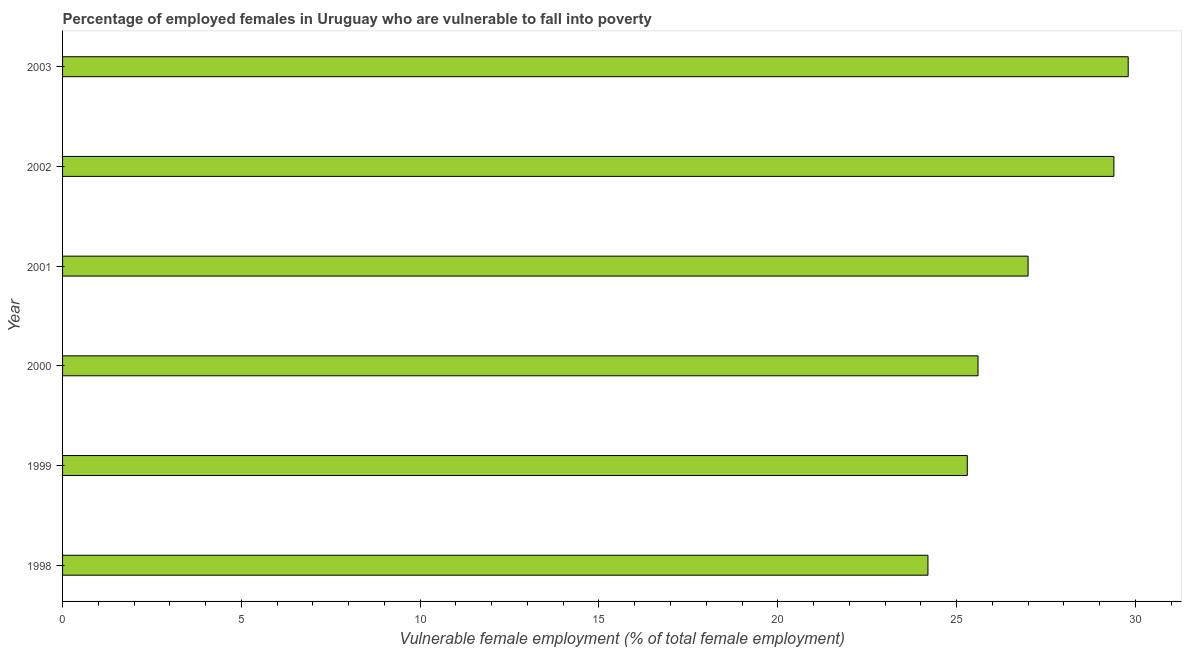Does the graph contain grids?
Your response must be concise. No. What is the title of the graph?
Provide a short and direct response. Percentage of employed females in Uruguay who are vulnerable to fall into poverty. What is the label or title of the X-axis?
Provide a succinct answer. Vulnerable female employment (% of total female employment). What is the percentage of employed females who are vulnerable to fall into poverty in 2000?
Your answer should be compact. 25.6. Across all years, what is the maximum percentage of employed females who are vulnerable to fall into poverty?
Provide a succinct answer. 29.8. Across all years, what is the minimum percentage of employed females who are vulnerable to fall into poverty?
Your answer should be compact. 24.2. What is the sum of the percentage of employed females who are vulnerable to fall into poverty?
Your answer should be very brief. 161.3. What is the average percentage of employed females who are vulnerable to fall into poverty per year?
Provide a short and direct response. 26.88. What is the median percentage of employed females who are vulnerable to fall into poverty?
Ensure brevity in your answer.  26.3. In how many years, is the percentage of employed females who are vulnerable to fall into poverty greater than 3 %?
Your response must be concise. 6. What is the ratio of the percentage of employed females who are vulnerable to fall into poverty in 2000 to that in 2001?
Offer a very short reply. 0.95. Is the difference between the percentage of employed females who are vulnerable to fall into poverty in 1998 and 2002 greater than the difference between any two years?
Give a very brief answer. No. What is the difference between the highest and the second highest percentage of employed females who are vulnerable to fall into poverty?
Offer a very short reply. 0.4. Is the sum of the percentage of employed females who are vulnerable to fall into poverty in 1998 and 2000 greater than the maximum percentage of employed females who are vulnerable to fall into poverty across all years?
Give a very brief answer. Yes. How many bars are there?
Give a very brief answer. 6. Are the values on the major ticks of X-axis written in scientific E-notation?
Make the answer very short. No. What is the Vulnerable female employment (% of total female employment) of 1998?
Your answer should be very brief. 24.2. What is the Vulnerable female employment (% of total female employment) in 1999?
Provide a short and direct response. 25.3. What is the Vulnerable female employment (% of total female employment) in 2000?
Your answer should be compact. 25.6. What is the Vulnerable female employment (% of total female employment) of 2001?
Give a very brief answer. 27. What is the Vulnerable female employment (% of total female employment) of 2002?
Your answer should be compact. 29.4. What is the Vulnerable female employment (% of total female employment) in 2003?
Provide a short and direct response. 29.8. What is the difference between the Vulnerable female employment (% of total female employment) in 1998 and 1999?
Your answer should be compact. -1.1. What is the difference between the Vulnerable female employment (% of total female employment) in 1998 and 2002?
Provide a succinct answer. -5.2. What is the difference between the Vulnerable female employment (% of total female employment) in 1998 and 2003?
Offer a very short reply. -5.6. What is the difference between the Vulnerable female employment (% of total female employment) in 1999 and 2001?
Your answer should be very brief. -1.7. What is the difference between the Vulnerable female employment (% of total female employment) in 2000 and 2001?
Provide a succinct answer. -1.4. What is the difference between the Vulnerable female employment (% of total female employment) in 2000 and 2002?
Offer a very short reply. -3.8. What is the difference between the Vulnerable female employment (% of total female employment) in 2000 and 2003?
Offer a terse response. -4.2. What is the difference between the Vulnerable female employment (% of total female employment) in 2001 and 2002?
Give a very brief answer. -2.4. What is the difference between the Vulnerable female employment (% of total female employment) in 2002 and 2003?
Your answer should be compact. -0.4. What is the ratio of the Vulnerable female employment (% of total female employment) in 1998 to that in 1999?
Your response must be concise. 0.96. What is the ratio of the Vulnerable female employment (% of total female employment) in 1998 to that in 2000?
Provide a succinct answer. 0.94. What is the ratio of the Vulnerable female employment (% of total female employment) in 1998 to that in 2001?
Keep it short and to the point. 0.9. What is the ratio of the Vulnerable female employment (% of total female employment) in 1998 to that in 2002?
Offer a very short reply. 0.82. What is the ratio of the Vulnerable female employment (% of total female employment) in 1998 to that in 2003?
Your answer should be compact. 0.81. What is the ratio of the Vulnerable female employment (% of total female employment) in 1999 to that in 2001?
Ensure brevity in your answer.  0.94. What is the ratio of the Vulnerable female employment (% of total female employment) in 1999 to that in 2002?
Offer a very short reply. 0.86. What is the ratio of the Vulnerable female employment (% of total female employment) in 1999 to that in 2003?
Make the answer very short. 0.85. What is the ratio of the Vulnerable female employment (% of total female employment) in 2000 to that in 2001?
Provide a short and direct response. 0.95. What is the ratio of the Vulnerable female employment (% of total female employment) in 2000 to that in 2002?
Offer a terse response. 0.87. What is the ratio of the Vulnerable female employment (% of total female employment) in 2000 to that in 2003?
Keep it short and to the point. 0.86. What is the ratio of the Vulnerable female employment (% of total female employment) in 2001 to that in 2002?
Ensure brevity in your answer.  0.92. What is the ratio of the Vulnerable female employment (% of total female employment) in 2001 to that in 2003?
Provide a short and direct response. 0.91. What is the ratio of the Vulnerable female employment (% of total female employment) in 2002 to that in 2003?
Your answer should be very brief. 0.99. 